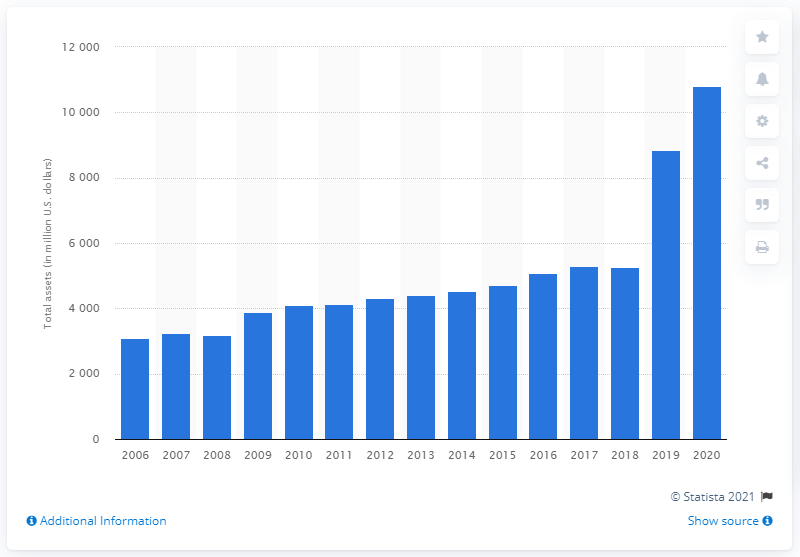Identify some key points in this picture. In 2020, Hasbro's total assets were 10,818.4. 